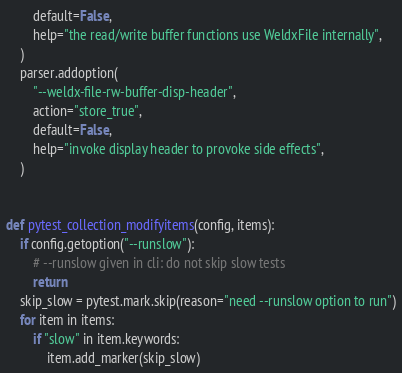<code> <loc_0><loc_0><loc_500><loc_500><_Python_>        default=False,
        help="the read/write buffer functions use WeldxFile internally",
    )
    parser.addoption(
        "--weldx-file-rw-buffer-disp-header",
        action="store_true",
        default=False,
        help="invoke display header to provoke side effects",
    )


def pytest_collection_modifyitems(config, items):
    if config.getoption("--runslow"):
        # --runslow given in cli: do not skip slow tests
        return
    skip_slow = pytest.mark.skip(reason="need --runslow option to run")
    for item in items:
        if "slow" in item.keywords:
            item.add_marker(skip_slow)
</code> 